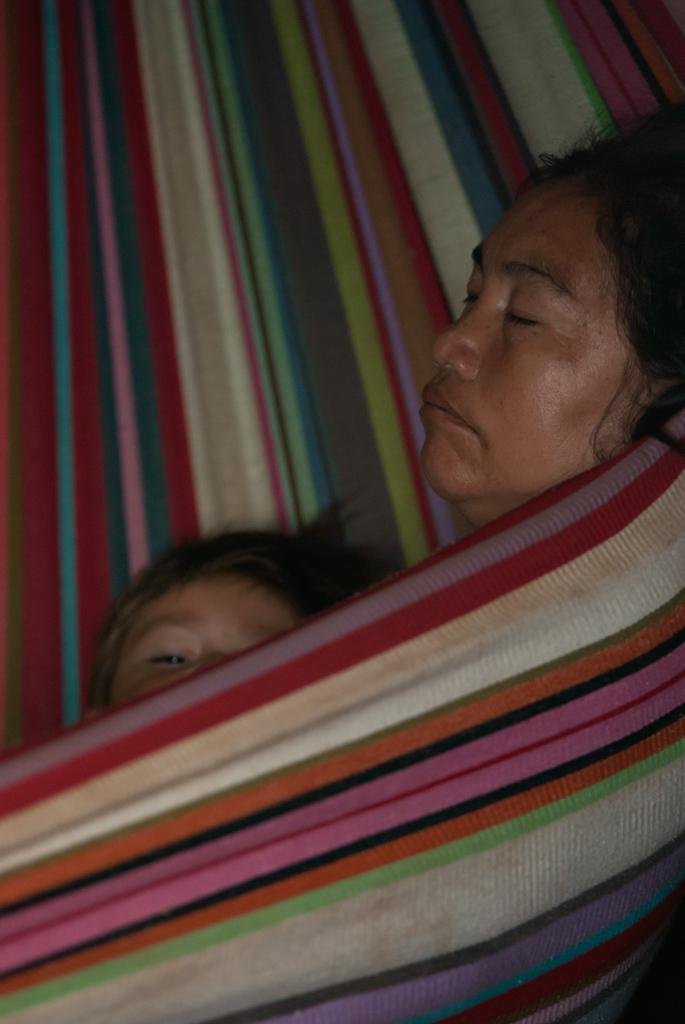What is the main subject of the image? There is a colorful object in the image. Who or what is on the colorful object? A child and a woman are present on the colorful object. How many noses can be seen on the colorful object in the image? There is no mention of noses in the image, so it is impossible to determine how many there are. 